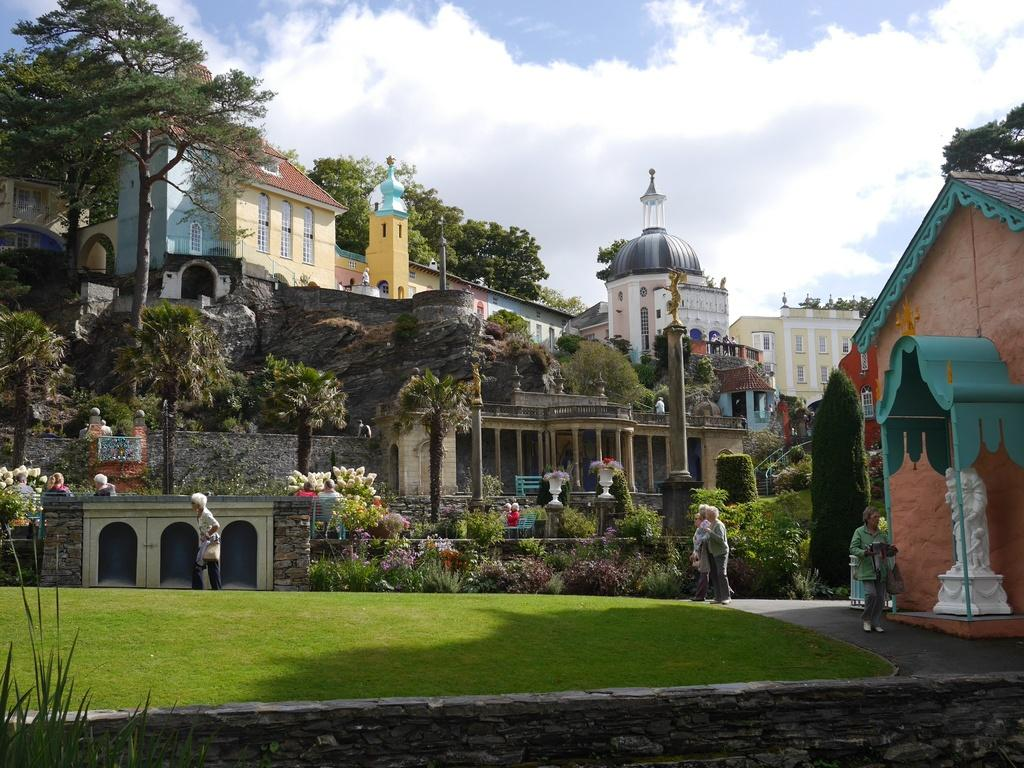What types of structures can be seen in the image? There are houses and buildings in the image. What natural elements are present in the image? There are trees, plants, grass, and the sky visible in the image. Are there any living beings in the image? Yes, there are persons in the image. What additional features can be found in the image? There are statues and at least one pillar in the image. What is the condition of the sky in the image? The sky is visible with clouds in the image. Can you tell me how many knives are being used by the persons in the image? There is no mention of knives in the image; the persons are not using any knives. What type of brake system is installed on the statues in the image? There are no brake systems mentioned or visible in the image; the statues do not have any brake systems. 